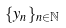Convert formula to latex. <formula><loc_0><loc_0><loc_500><loc_500>\{ y _ { n } \} _ { n \in \mathbb { N } }</formula> 